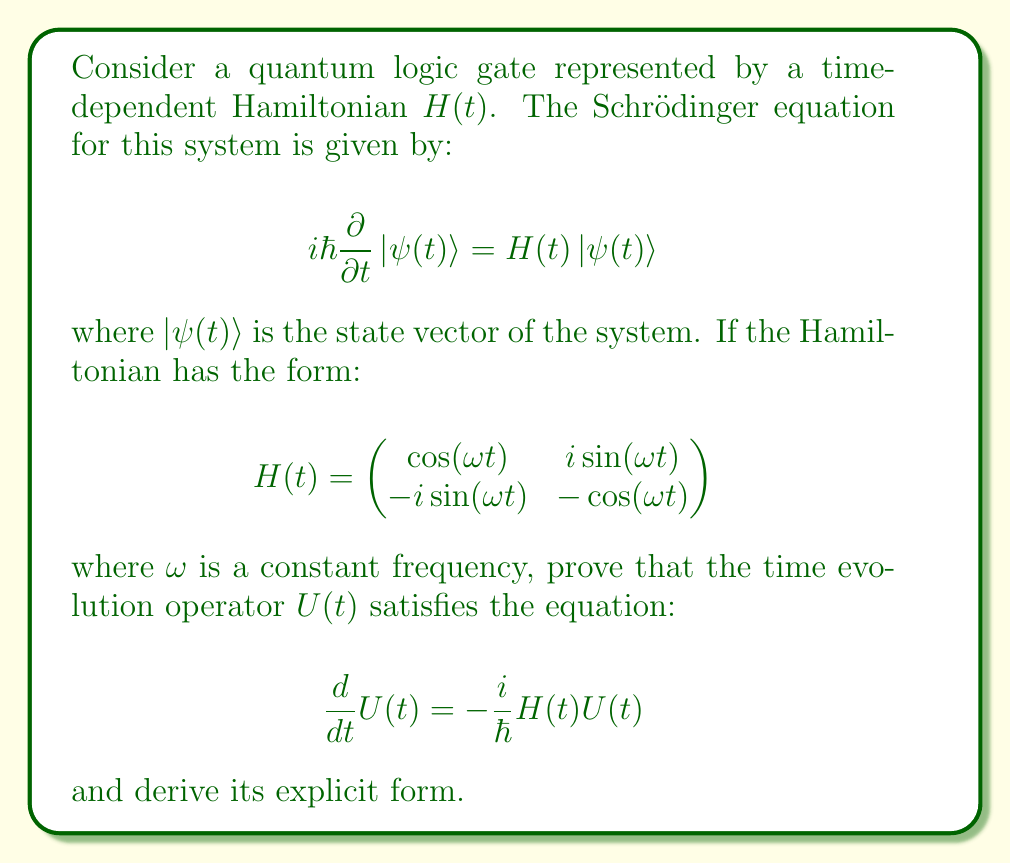Provide a solution to this math problem. To prove this and derive the time evolution operator, we'll follow these steps:

1) First, recall that the time evolution operator $U(t)$ is defined by:

   $$|\psi(t)\rangle = U(t)|\psi(0)\rangle$$

2) Substituting this into the Schrödinger equation:

   $$i\hbar\frac{\partial}{\partial t}(U(t)|\psi(0)\rangle) = H(t)U(t)|\psi(0)\rangle$$

3) Using the product rule and noting that $|\psi(0)\rangle$ is constant:

   $$i\hbar\frac{d}{dt}U(t)|\psi(0)\rangle = H(t)U(t)|\psi(0)\rangle$$

4) Since this must hold for any initial state $|\psi(0)\rangle$, we can conclude:

   $$i\hbar\frac{d}{dt}U(t) = H(t)U(t)$$

5) Rearranging this equation proves the first part:

   $$\frac{d}{dt}U(t) = -\frac{i}{\hbar}H(t)U(t)$$

6) To derive the explicit form of $U(t)$, we can use the method of ansatz. Given the form of $H(t)$, we can guess that $U(t)$ has the form:

   $$U(t) = \begin{pmatrix}
   \cos(\frac{\omega t}{2}) - i\sin(\frac{\omega t}{2}) & 0 \\
   0 & \cos(\frac{\omega t}{2}) + i\sin(\frac{\omega t}{2})
   \end{pmatrix}$$

7) To verify this, we can substitute it into the equation from step 5:

   $$\frac{d}{dt}U(t) = \begin{pmatrix}
   -\frac{\omega}{2}\sin(\frac{\omega t}{2}) - i\frac{\omega}{2}\cos(\frac{\omega t}{2}) & 0 \\
   0 & -\frac{\omega}{2}\sin(\frac{\omega t}{2}) + i\frac{\omega}{2}\cos(\frac{\omega t}{2})
   \end{pmatrix}$$

   $$-\frac{i}{\hbar}H(t)U(t) = -\frac{i}{\hbar}\begin{pmatrix}
   \cos(\omega t)(\cos(\frac{\omega t}{2}) - i\sin(\frac{\omega t}{2})) & i\sin(\omega t)(\cos(\frac{\omega t}{2}) + i\sin(\frac{\omega t}{2})) \\
   -i\sin(\omega t)(\cos(\frac{\omega t}{2}) - i\sin(\frac{\omega t}{2})) & -\cos(\omega t)(\cos(\frac{\omega t}{2}) + i\sin(\frac{\omega t}{2}))
   \end{pmatrix}$$

8) Using trigonometric identities, we can show that these are indeed equal, confirming our ansatz for $U(t)$.

This derivation demonstrates how the Schrödinger equation leads to the time evolution of quantum states, which is crucial for understanding quantum logic operations.
Answer: The time evolution operator $U(t)$ for the given Hamiltonian is:

$$U(t) = \begin{pmatrix}
\cos(\frac{\omega t}{2}) - i\sin(\frac{\omega t}{2}) & 0 \\
0 & \cos(\frac{\omega t}{2}) + i\sin(\frac{\omega t}{2})
\end{pmatrix}$$

This operator satisfies the equation $\frac{d}{dt}U(t) = -\frac{i}{\hbar}H(t)U(t)$, as proven in the explanation. 